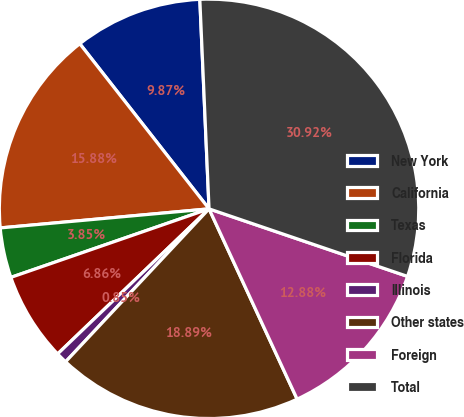Convert chart. <chart><loc_0><loc_0><loc_500><loc_500><pie_chart><fcel>New York<fcel>California<fcel>Texas<fcel>Florida<fcel>Illinois<fcel>Other states<fcel>Foreign<fcel>Total<nl><fcel>9.87%<fcel>15.88%<fcel>3.85%<fcel>6.86%<fcel>0.85%<fcel>18.89%<fcel>12.88%<fcel>30.92%<nl></chart> 